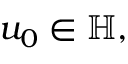Convert formula to latex. <formula><loc_0><loc_0><loc_500><loc_500>u _ { 0 } \in \mathbb { H } ,</formula> 